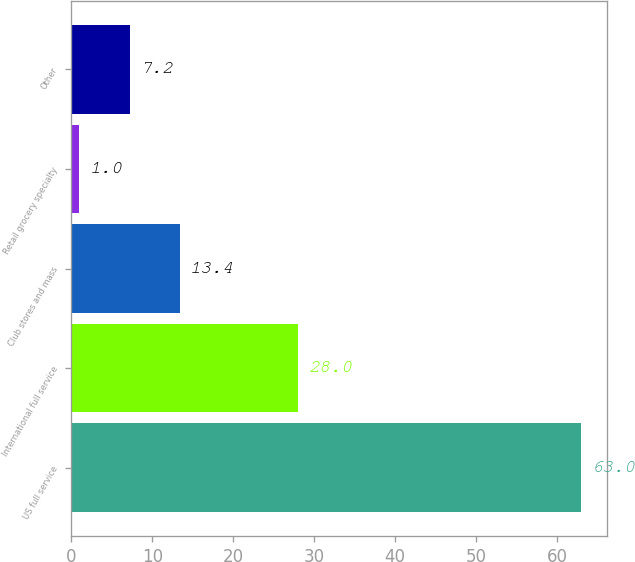Convert chart to OTSL. <chart><loc_0><loc_0><loc_500><loc_500><bar_chart><fcel>US full service<fcel>International full service<fcel>Club stores and mass<fcel>Retail grocery specialty<fcel>Other<nl><fcel>63<fcel>28<fcel>13.4<fcel>1<fcel>7.2<nl></chart> 